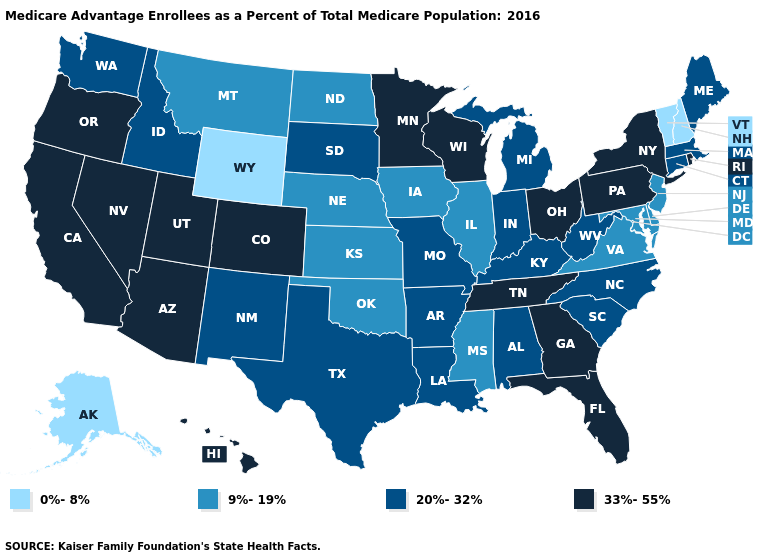Does Washington have the highest value in the West?
Keep it brief. No. How many symbols are there in the legend?
Quick response, please. 4. What is the value of Idaho?
Give a very brief answer. 20%-32%. Which states have the highest value in the USA?
Give a very brief answer. Arizona, California, Colorado, Florida, Georgia, Hawaii, Minnesota, Nevada, New York, Ohio, Oregon, Pennsylvania, Rhode Island, Tennessee, Utah, Wisconsin. Name the states that have a value in the range 20%-32%?
Answer briefly. Alabama, Arkansas, Connecticut, Idaho, Indiana, Kentucky, Louisiana, Massachusetts, Maine, Michigan, Missouri, North Carolina, New Mexico, South Carolina, South Dakota, Texas, Washington, West Virginia. Name the states that have a value in the range 9%-19%?
Answer briefly. Delaware, Iowa, Illinois, Kansas, Maryland, Mississippi, Montana, North Dakota, Nebraska, New Jersey, Oklahoma, Virginia. What is the highest value in the MidWest ?
Short answer required. 33%-55%. Does the map have missing data?
Answer briefly. No. Among the states that border New Jersey , which have the lowest value?
Write a very short answer. Delaware. What is the highest value in the Northeast ?
Short answer required. 33%-55%. Name the states that have a value in the range 9%-19%?
Concise answer only. Delaware, Iowa, Illinois, Kansas, Maryland, Mississippi, Montana, North Dakota, Nebraska, New Jersey, Oklahoma, Virginia. Which states have the lowest value in the MidWest?
Answer briefly. Iowa, Illinois, Kansas, North Dakota, Nebraska. What is the value of Wyoming?
Write a very short answer. 0%-8%. Which states have the lowest value in the Northeast?
Concise answer only. New Hampshire, Vermont. Name the states that have a value in the range 9%-19%?
Short answer required. Delaware, Iowa, Illinois, Kansas, Maryland, Mississippi, Montana, North Dakota, Nebraska, New Jersey, Oklahoma, Virginia. 